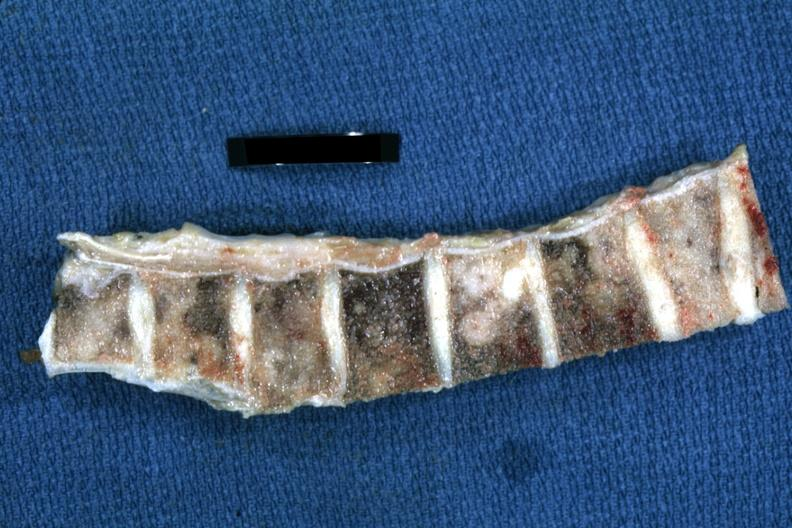what does this image show?
Answer the question using a single word or phrase. Fixed tissue easily seen metastatic lesions breast primary 